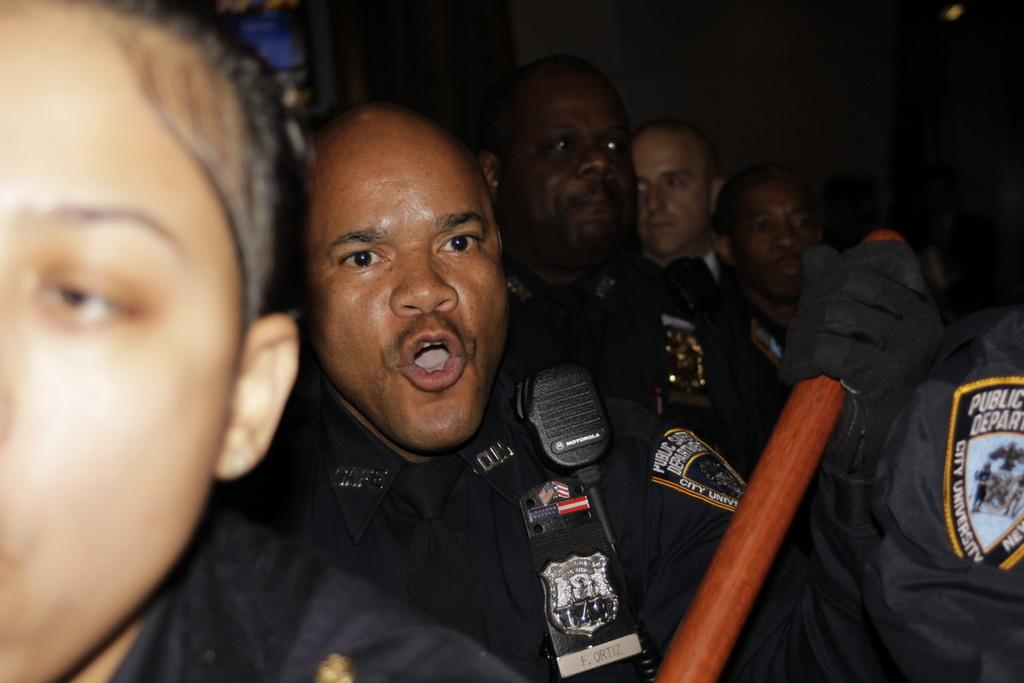How many people are in the image? There is a group of persons in the image. What is the person in the middle holding? The person in the middle is holding a wooden object. What type of toe is visible on the person in the image? There is no toe visible in the image; it only shows a group of persons and a person holding a wooden object. 